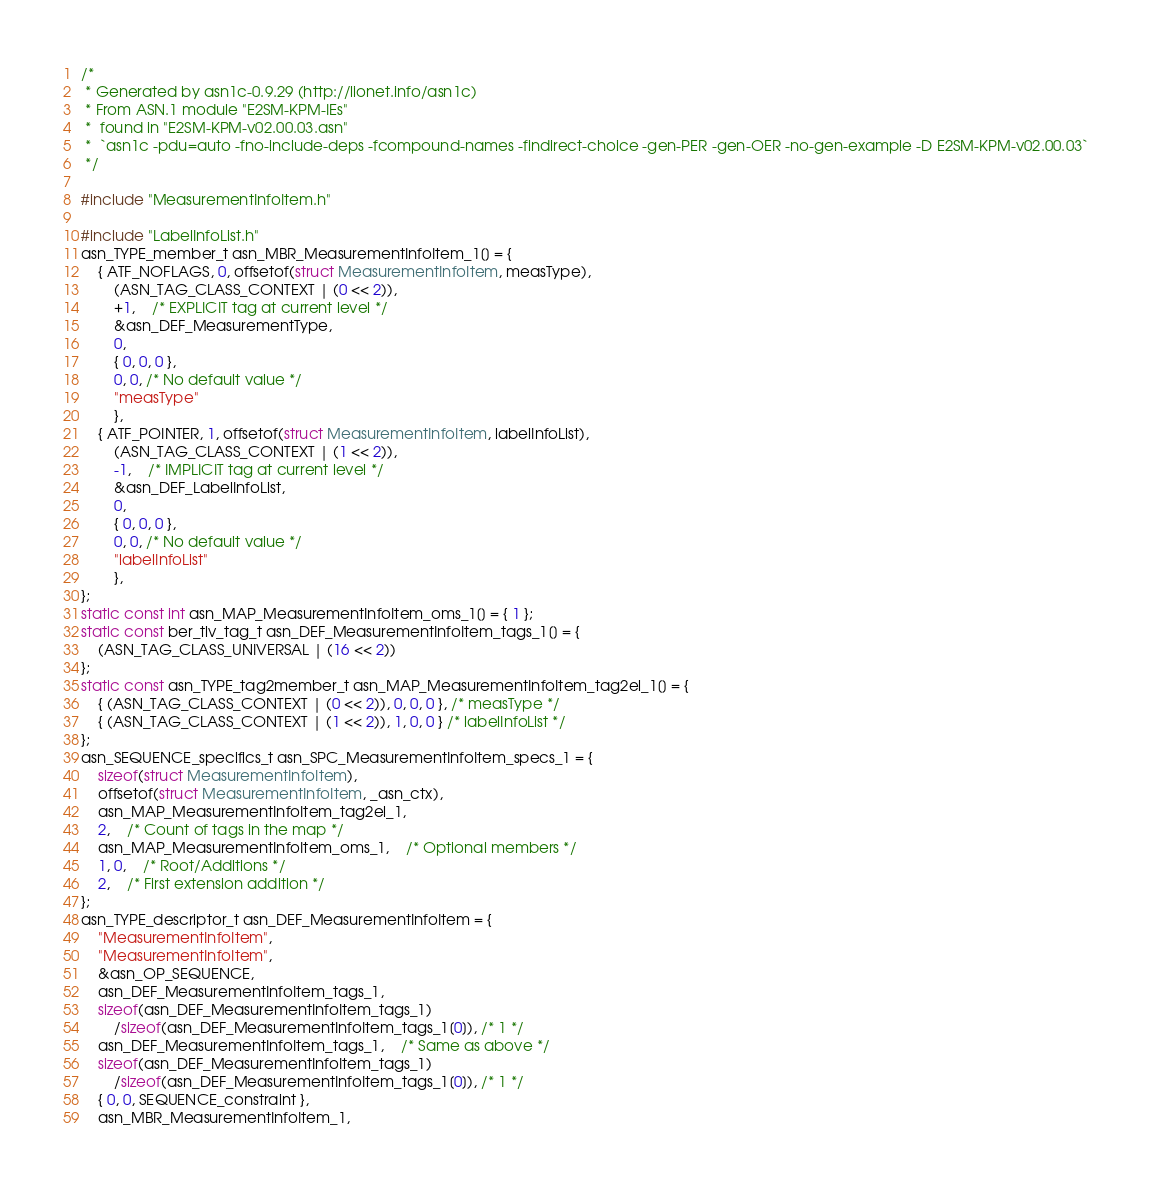<code> <loc_0><loc_0><loc_500><loc_500><_C_>/*
 * Generated by asn1c-0.9.29 (http://lionet.info/asn1c)
 * From ASN.1 module "E2SM-KPM-IEs"
 * 	found in "E2SM-KPM-v02.00.03.asn"
 * 	`asn1c -pdu=auto -fno-include-deps -fcompound-names -findirect-choice -gen-PER -gen-OER -no-gen-example -D E2SM-KPM-v02.00.03`
 */

#include "MeasurementInfoItem.h"

#include "LabelInfoList.h"
asn_TYPE_member_t asn_MBR_MeasurementInfoItem_1[] = {
	{ ATF_NOFLAGS, 0, offsetof(struct MeasurementInfoItem, measType),
		(ASN_TAG_CLASS_CONTEXT | (0 << 2)),
		+1,	/* EXPLICIT tag at current level */
		&asn_DEF_MeasurementType,
		0,
		{ 0, 0, 0 },
		0, 0, /* No default value */
		"measType"
		},
	{ ATF_POINTER, 1, offsetof(struct MeasurementInfoItem, labelInfoList),
		(ASN_TAG_CLASS_CONTEXT | (1 << 2)),
		-1,	/* IMPLICIT tag at current level */
		&asn_DEF_LabelInfoList,
		0,
		{ 0, 0, 0 },
		0, 0, /* No default value */
		"labelInfoList"
		},
};
static const int asn_MAP_MeasurementInfoItem_oms_1[] = { 1 };
static const ber_tlv_tag_t asn_DEF_MeasurementInfoItem_tags_1[] = {
	(ASN_TAG_CLASS_UNIVERSAL | (16 << 2))
};
static const asn_TYPE_tag2member_t asn_MAP_MeasurementInfoItem_tag2el_1[] = {
    { (ASN_TAG_CLASS_CONTEXT | (0 << 2)), 0, 0, 0 }, /* measType */
    { (ASN_TAG_CLASS_CONTEXT | (1 << 2)), 1, 0, 0 } /* labelInfoList */
};
asn_SEQUENCE_specifics_t asn_SPC_MeasurementInfoItem_specs_1 = {
	sizeof(struct MeasurementInfoItem),
	offsetof(struct MeasurementInfoItem, _asn_ctx),
	asn_MAP_MeasurementInfoItem_tag2el_1,
	2,	/* Count of tags in the map */
	asn_MAP_MeasurementInfoItem_oms_1,	/* Optional members */
	1, 0,	/* Root/Additions */
	2,	/* First extension addition */
};
asn_TYPE_descriptor_t asn_DEF_MeasurementInfoItem = {
	"MeasurementInfoItem",
	"MeasurementInfoItem",
	&asn_OP_SEQUENCE,
	asn_DEF_MeasurementInfoItem_tags_1,
	sizeof(asn_DEF_MeasurementInfoItem_tags_1)
		/sizeof(asn_DEF_MeasurementInfoItem_tags_1[0]), /* 1 */
	asn_DEF_MeasurementInfoItem_tags_1,	/* Same as above */
	sizeof(asn_DEF_MeasurementInfoItem_tags_1)
		/sizeof(asn_DEF_MeasurementInfoItem_tags_1[0]), /* 1 */
	{ 0, 0, SEQUENCE_constraint },
	asn_MBR_MeasurementInfoItem_1,</code> 